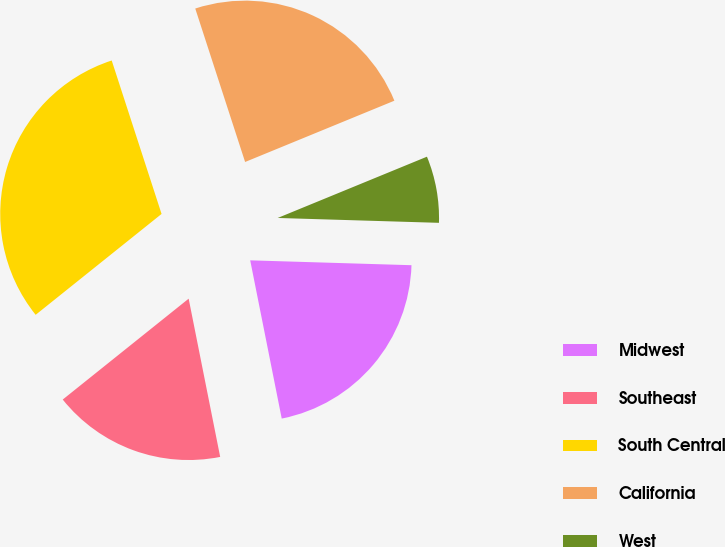Convert chart. <chart><loc_0><loc_0><loc_500><loc_500><pie_chart><fcel>Midwest<fcel>Southeast<fcel>South Central<fcel>California<fcel>West<nl><fcel>21.39%<fcel>17.38%<fcel>30.75%<fcel>23.8%<fcel>6.68%<nl></chart> 